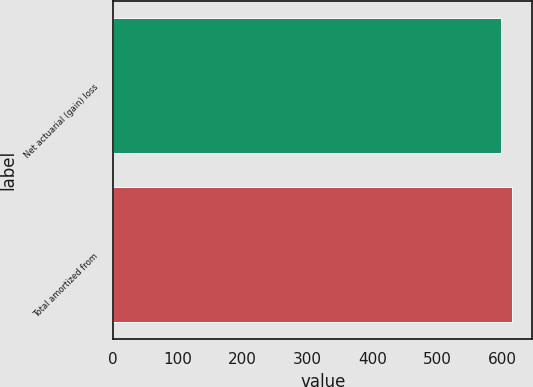<chart> <loc_0><loc_0><loc_500><loc_500><bar_chart><fcel>Net actuarial (gain) loss<fcel>Total amortized from<nl><fcel>598<fcel>616<nl></chart> 